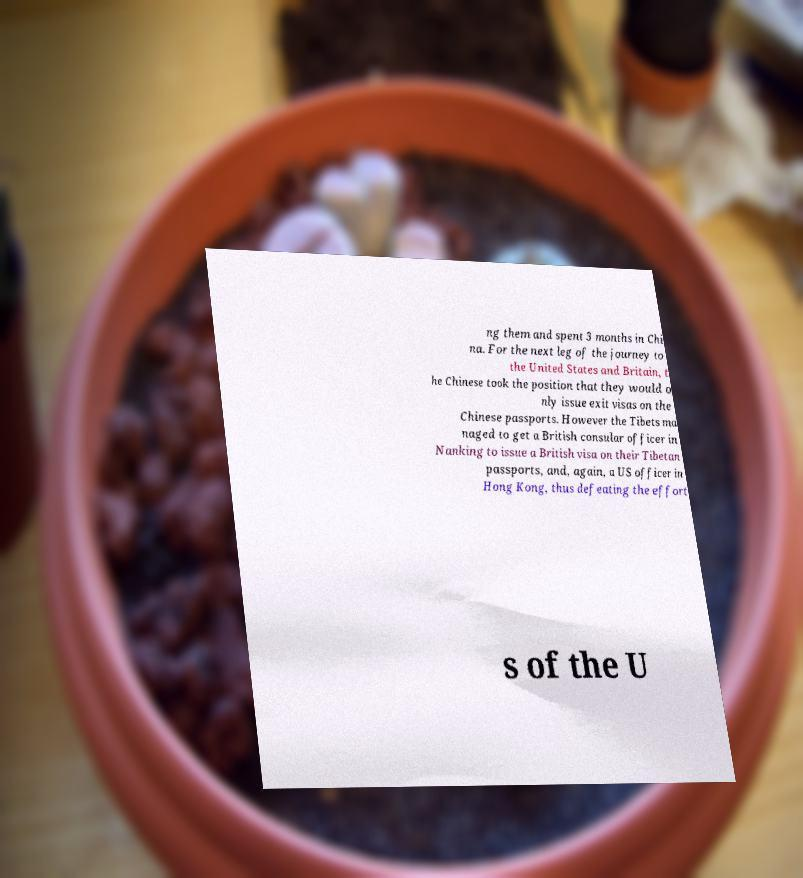There's text embedded in this image that I need extracted. Can you transcribe it verbatim? ng them and spent 3 months in Chi na. For the next leg of the journey to the United States and Britain, t he Chinese took the position that they would o nly issue exit visas on the Chinese passports. However the Tibets ma naged to get a British consular officer in Nanking to issue a British visa on their Tibetan passports, and, again, a US officer in Hong Kong, thus defeating the effort s of the U 